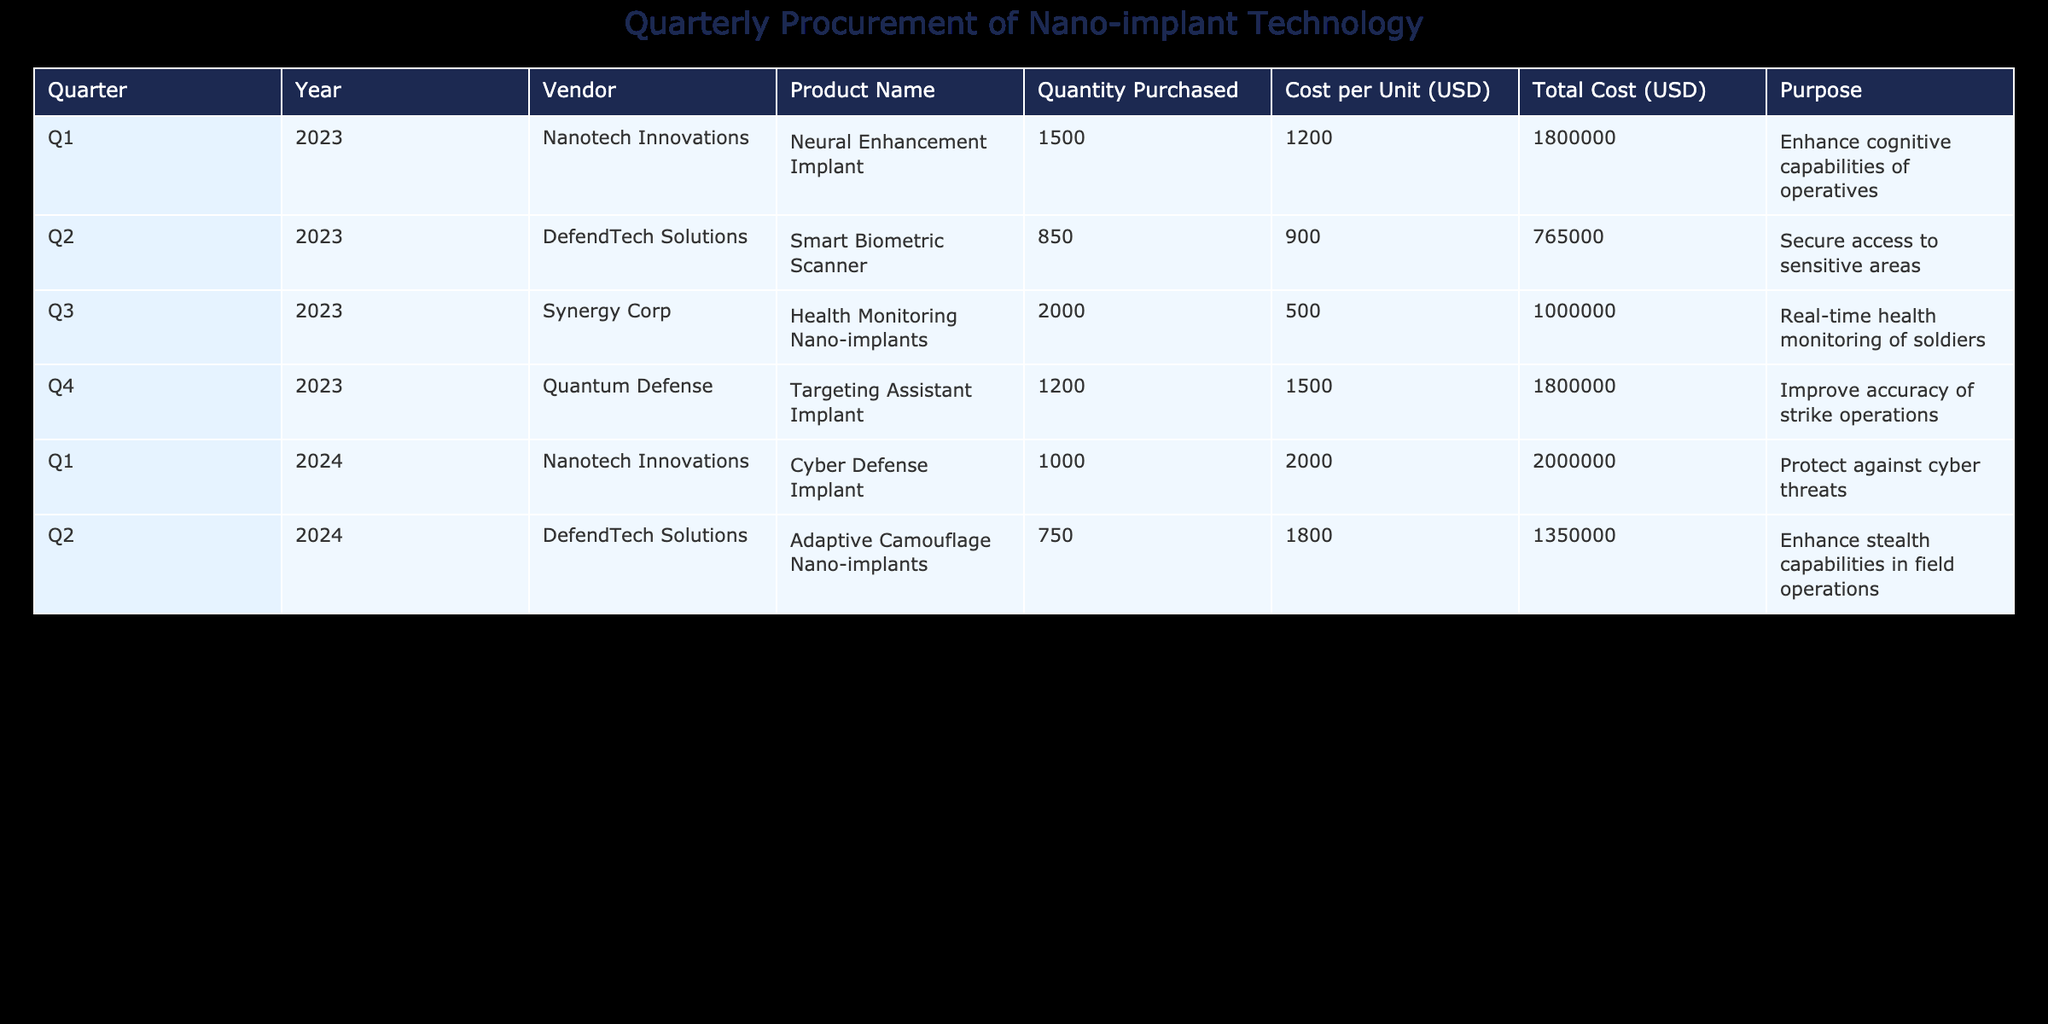What was the total cost of nano-implants purchased in Q3 2023? In Q3 2023, the total cost of the Health Monitoring Nano-implants was reported as 1,000,000 USD. This value is directly available in the "Total Cost (USD)" column for that quarter.
Answer: 1,000,000 USD Which vendor supplied the most units in Q1 2024? In Q1 2024, Nanotech Innovations supplied 1,000 Cyber Defense Implants. This is the highest quantity compared to the other vendors in the same quarter.
Answer: Nanotech Innovations Was the quantity of Smart Biometric Scanners purchased more than 1,000? The quantity of Smart Biometric Scanners purchased in Q2 2023 is 850, which is less than 1,000. This is confirmed by checking the respective row for that product.
Answer: No What is the average cost per unit of all nano-implants purchased in 2023? The units purchased in 2023 were: Neural Enhancement Implant (1500 at 1200 USD), Smart Biometric Scanner (850 at 900 USD), Health Monitoring Nano-implants (2000 at 500 USD), and Targeting Assistant Implant (1200 at 1500 USD). The total cost is (1200*1500 + 900*850 + 500*2000 + 1500*1200) / (1500 + 850 + 2000 + 1200) = (1800000 + 765000 + 1000000 + 1800000) / 5550 = 4,827,000 / 5550 ≈ 868.51 USD.
Answer: Approximately 868.51 USD Which purpose had the highest total spending in 2023 based on the data? The purpose with the highest total spending in 2023 was "Enhance cognitive capabilities of operatives" with a total cost of 1,800,000 USD for the Neural Enhancement Implant. This is the only entry with the highest cost filter and other purposes had lower totals.
Answer: Enhance cognitive capabilities of operatives Did DefendTech Solutions provide any products in Q1 2024? DefendTech Solutions did not have any entries for products in Q1 2024 according to the table. The only vendor listed in that quarter is Nanotech Innovations.
Answer: No What is the total quantity of Adaptive Camouflage Nano-implants purchased across all quarters? The total quantity of Adaptive Camouflage Nano-implants was 750, as that's the only entry for this specific product in Q2 2024, thus directly taken as the total.
Answer: 750 Which product was purchased with the lowest cost per unit in 2023? The product purchased with the lowest cost per unit in 2023 was the Health Monitoring Nano-implants with a cost of 500 USD per unit. It's derived from comparing the costs listed for each product within that year.
Answer: Health Monitoring Nano-implants 